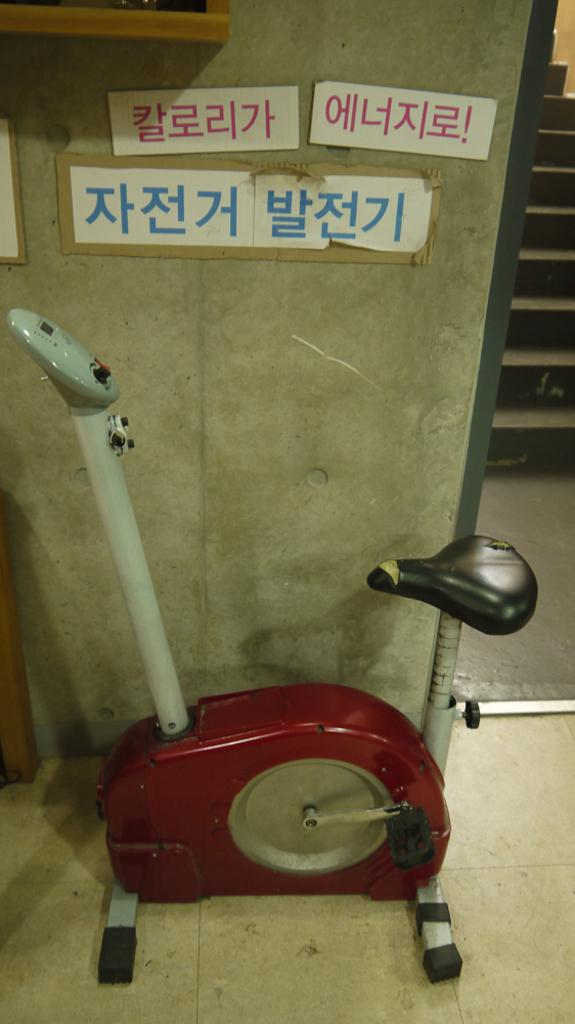<image>
Present a compact description of the photo's key features. some Japanese writing that is on a wall 